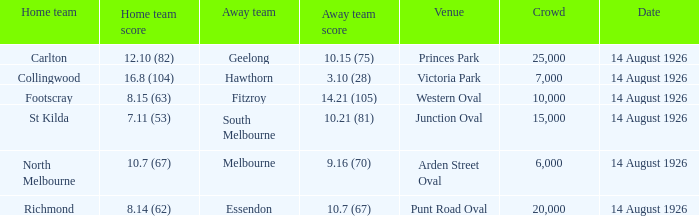As the away team, what was the largest crowd essendon has ever played before? 20000.0. 